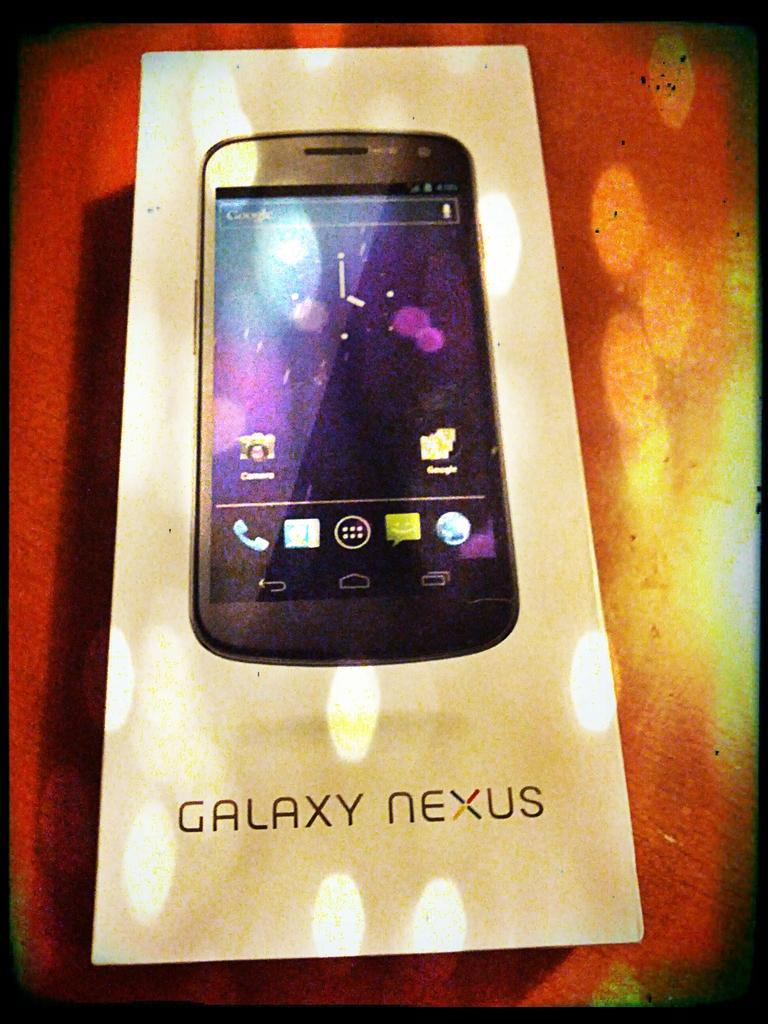Provide a one-sentence caption for the provided image. A Galaxy Nexus smart phone box on a table. 